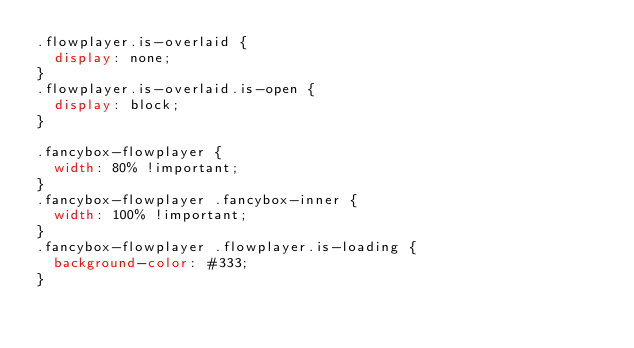<code> <loc_0><loc_0><loc_500><loc_500><_CSS_>.flowplayer.is-overlaid {
  display: none;
}
.flowplayer.is-overlaid.is-open {
  display: block;
}

.fancybox-flowplayer {
  width: 80% !important;
}
.fancybox-flowplayer .fancybox-inner {
  width: 100% !important;
}
.fancybox-flowplayer .flowplayer.is-loading {
  background-color: #333;
}</code> 